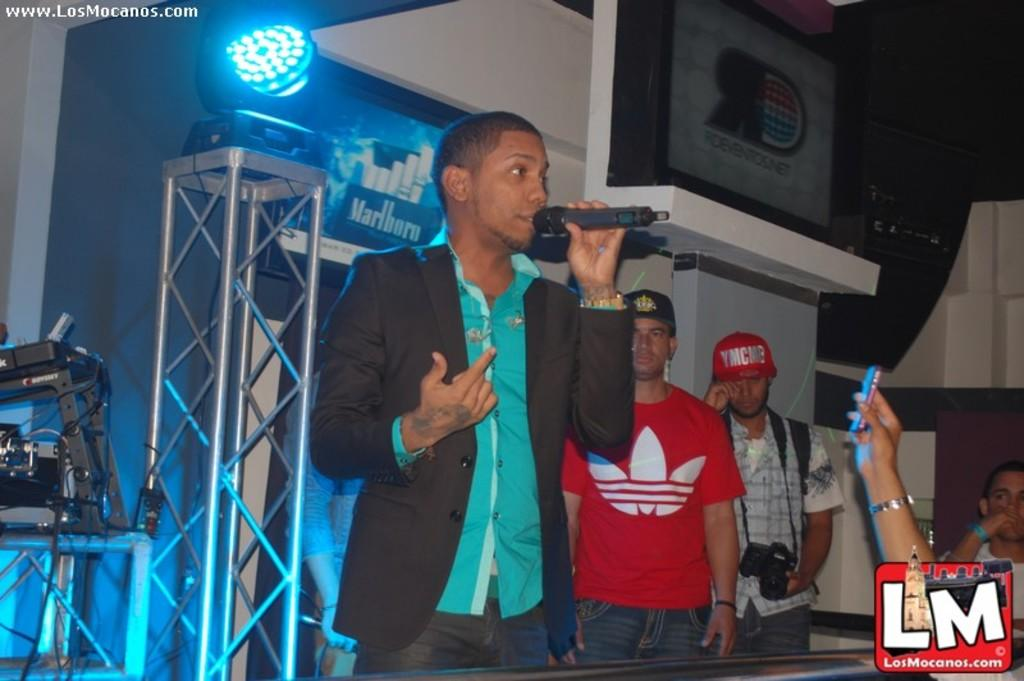What is happening in the image? There are people standing in the image. Can you describe any specific actions or objects being held by the people? One man is holding a microphone. What can be seen in the background of the image? There is a light on an iron stand in the background. Is there any text or symbol present in the image? Yes, there is a logo in the bottom right corner of the image. What type of bath can be seen in the image? There is no bath present in the image. What thrilling activity are the people participating in within the image? The image does not depict any thrilling activities; it simply shows people standing and one man holding a microphone. 